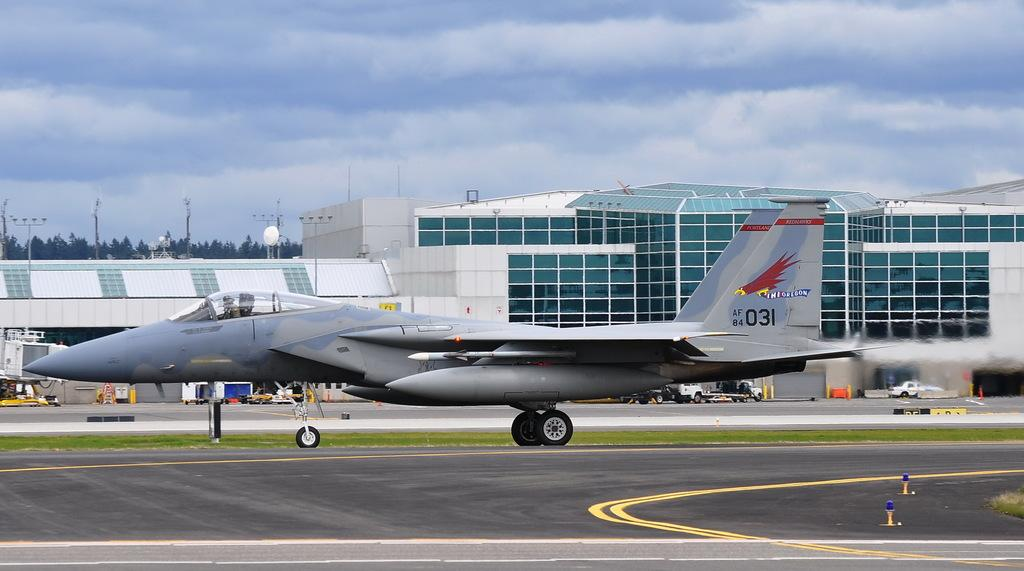Provide a one-sentence caption for the provided image. A jet is on a runway with the number 031 and a red hawk on its tail wing. 